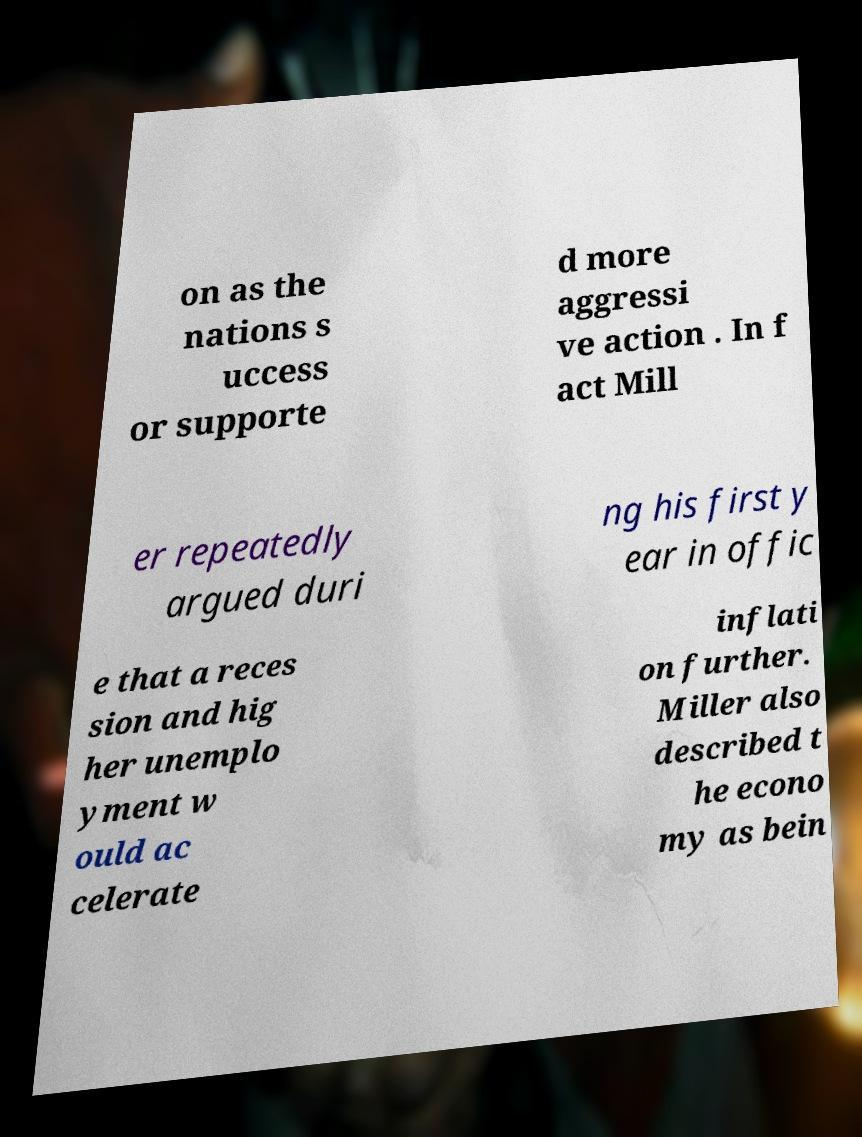Could you extract and type out the text from this image? on as the nations s uccess or supporte d more aggressi ve action . In f act Mill er repeatedly argued duri ng his first y ear in offic e that a reces sion and hig her unemplo yment w ould ac celerate inflati on further. Miller also described t he econo my as bein 